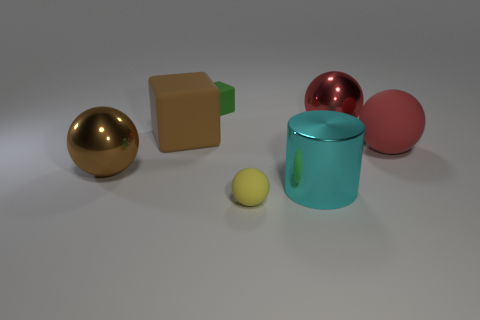Subtract all green spheres. Subtract all purple cylinders. How many spheres are left? 4 Add 1 yellow shiny blocks. How many objects exist? 8 Subtract all cubes. How many objects are left? 5 Add 3 tiny yellow balls. How many tiny yellow balls exist? 4 Subtract 0 yellow cylinders. How many objects are left? 7 Subtract all big shiny blocks. Subtract all big metal cylinders. How many objects are left? 6 Add 4 large shiny objects. How many large shiny objects are left? 7 